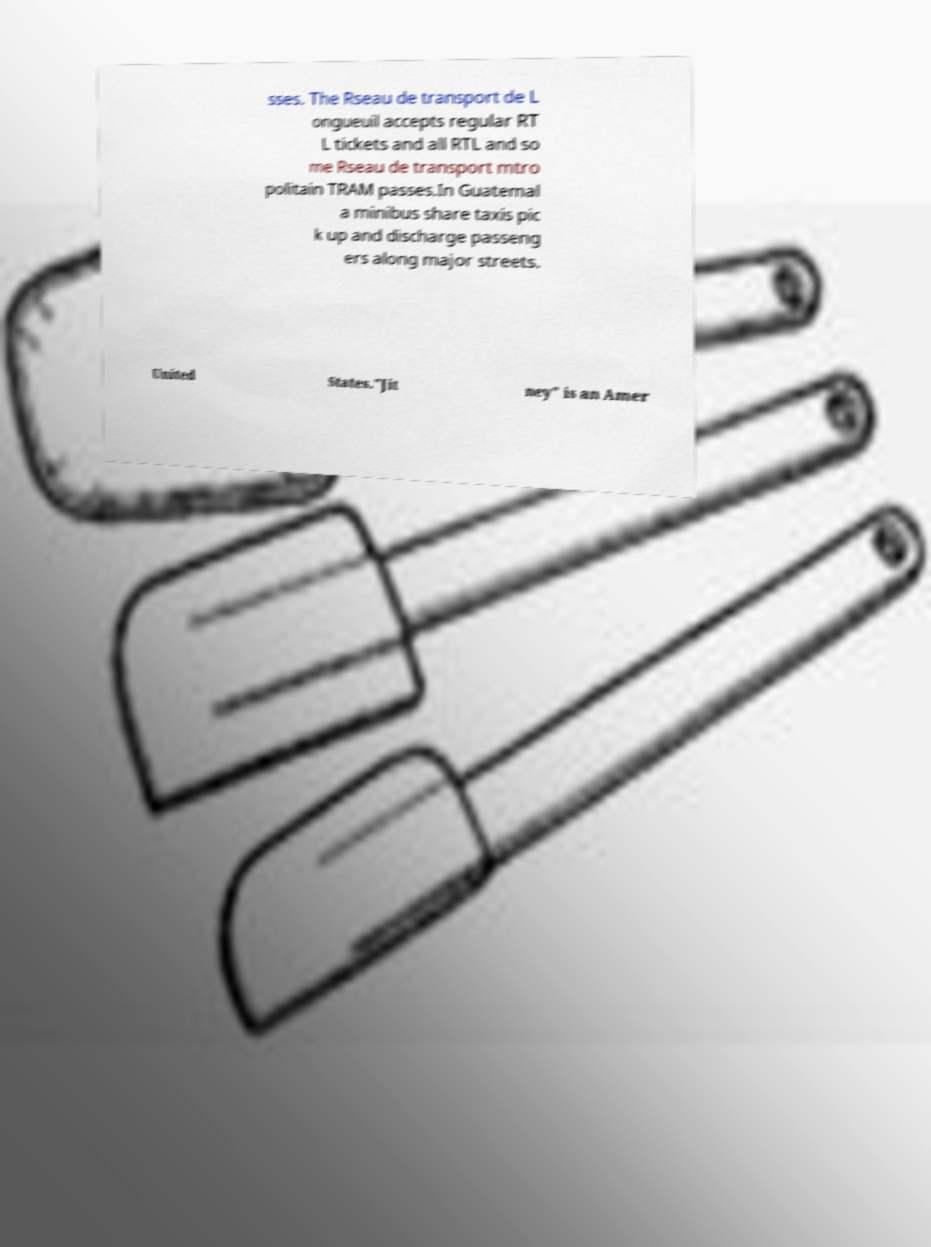There's text embedded in this image that I need extracted. Can you transcribe it verbatim? sses. The Rseau de transport de L ongueuil accepts regular RT L tickets and all RTL and so me Rseau de transport mtro politain TRAM passes.In Guatemal a minibus share taxis pic k up and discharge passeng ers along major streets. United States."Jit ney" is an Amer 